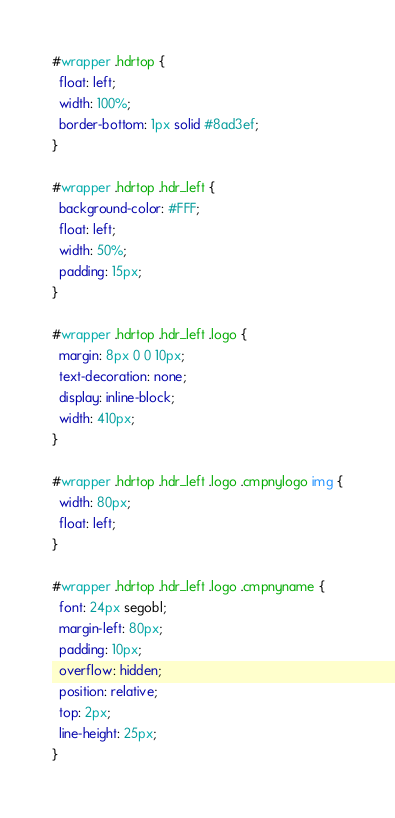<code> <loc_0><loc_0><loc_500><loc_500><_CSS_>#wrapper .hdrtop {
  float: left;
  width: 100%;
  border-bottom: 1px solid #8ad3ef;
}

#wrapper .hdrtop .hdr_left {
  background-color: #FFF;
  float: left;
  width: 50%;
  padding: 15px;
}

#wrapper .hdrtop .hdr_left .logo {
  margin: 8px 0 0 10px;
  text-decoration: none;
  display: inline-block;
  width: 410px;
}

#wrapper .hdrtop .hdr_left .logo .cmpnylogo img {
  width: 80px;
  float: left;
}

#wrapper .hdrtop .hdr_left .logo .cmpnyname {
  font: 24px segobl;
  margin-left: 80px;
  padding: 10px;
  overflow: hidden;
  position: relative;
  top: 2px;
  line-height: 25px;
}
</code> 